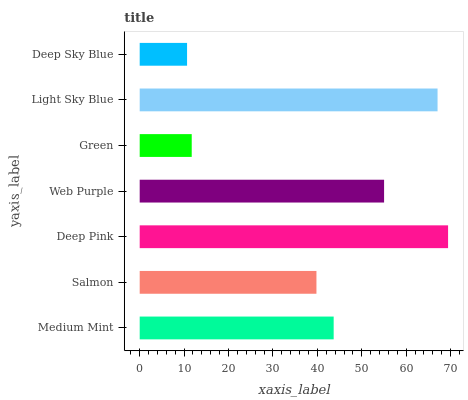Is Deep Sky Blue the minimum?
Answer yes or no. Yes. Is Deep Pink the maximum?
Answer yes or no. Yes. Is Salmon the minimum?
Answer yes or no. No. Is Salmon the maximum?
Answer yes or no. No. Is Medium Mint greater than Salmon?
Answer yes or no. Yes. Is Salmon less than Medium Mint?
Answer yes or no. Yes. Is Salmon greater than Medium Mint?
Answer yes or no. No. Is Medium Mint less than Salmon?
Answer yes or no. No. Is Medium Mint the high median?
Answer yes or no. Yes. Is Medium Mint the low median?
Answer yes or no. Yes. Is Deep Pink the high median?
Answer yes or no. No. Is Deep Sky Blue the low median?
Answer yes or no. No. 